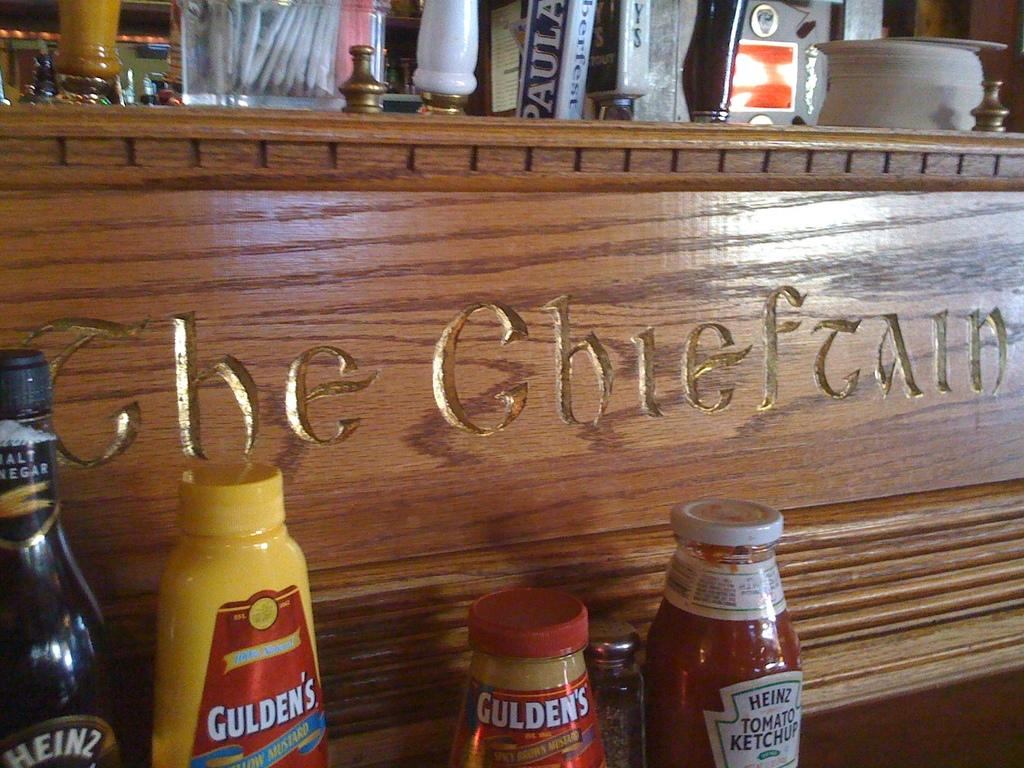<image>
Present a compact description of the photo's key features. Bottles of different condiments are seen on a bar with a Gulden's mustard bottle among the condiments. 